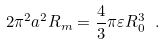<formula> <loc_0><loc_0><loc_500><loc_500>2 \pi ^ { 2 } a ^ { 2 } R _ { m } = \frac { 4 } { 3 } \pi \varepsilon R _ { 0 } ^ { 3 } \ .</formula> 